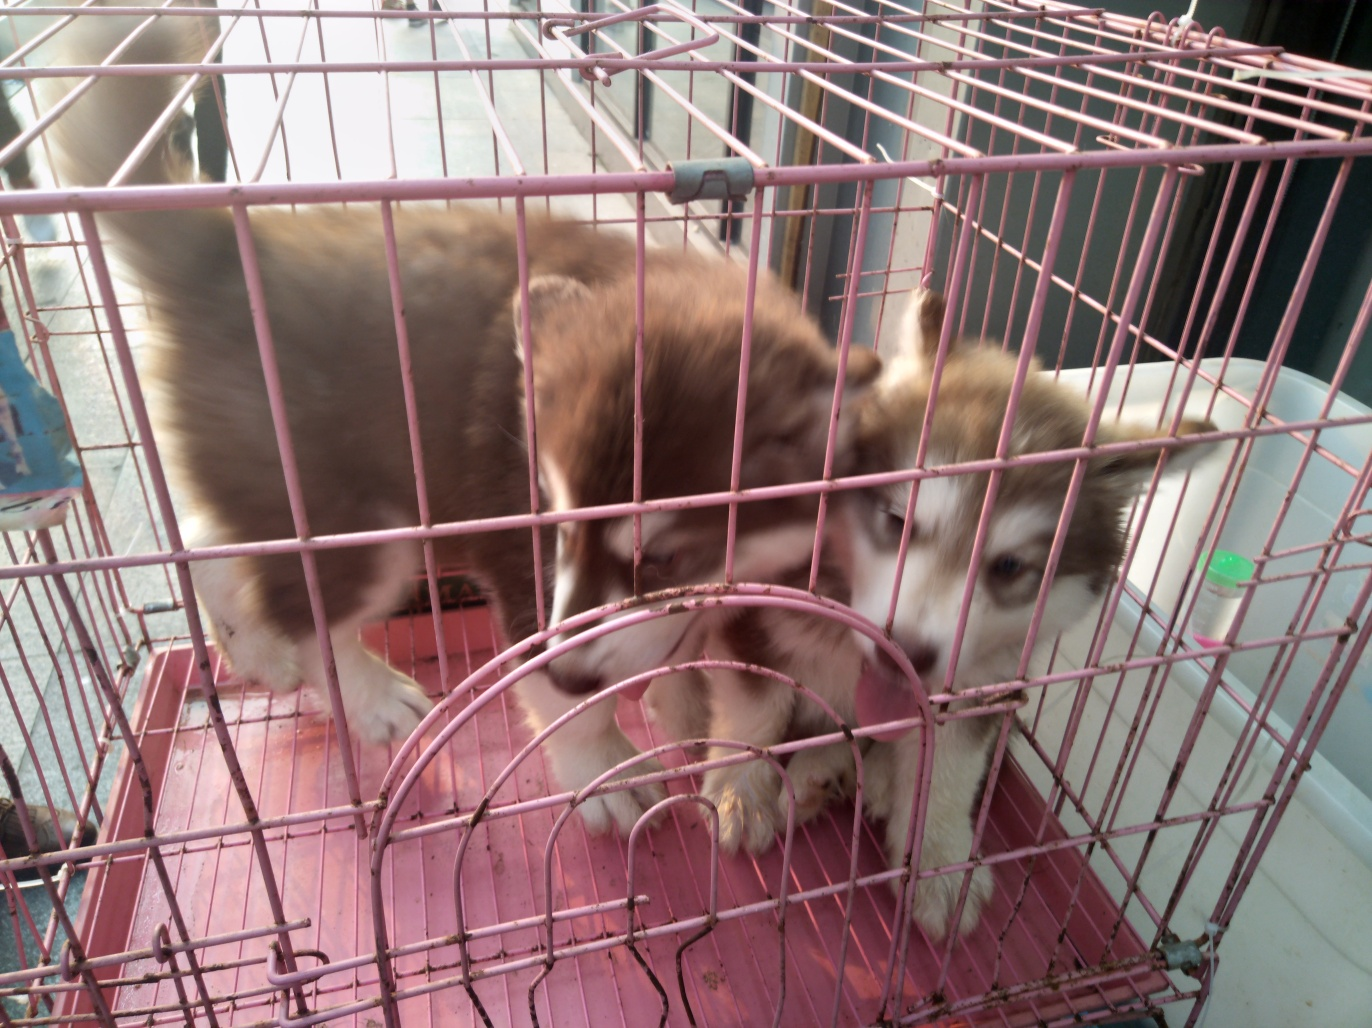How can one ensure the well-being of dogs in a cage? To ensure the well-being of caged dogs, it's critical to offer a cage large enough for them to stand, turn around, and lie down comfortably. Regular exercise, quality time outside the cage, proper ventilation, clean water, and nutritionally balanced food are imperative. Additionally, social interaction and mental stimulation through toys or training can help maintain a healthy, happy state of mind. 